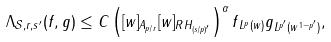<formula> <loc_0><loc_0><loc_500><loc_500>\Lambda _ { \mathcal { S } , r , s ^ { \prime } } ( f , g ) \leq C \left ( [ w ] _ { A _ { p / r } } [ w ] _ { R H _ { ( s / p ) ^ { \prime } } } \right ) ^ { \alpha } \| f \| _ { L ^ { p } ( w ) } \| g \| _ { L ^ { p ^ { \prime } } ( w ^ { 1 - p ^ { \prime } } ) } ,</formula> 